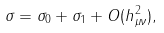<formula> <loc_0><loc_0><loc_500><loc_500>\sigma = \sigma _ { 0 } + \sigma _ { 1 } + O ( h _ { \mu \nu } ^ { 2 } ) ,</formula> 